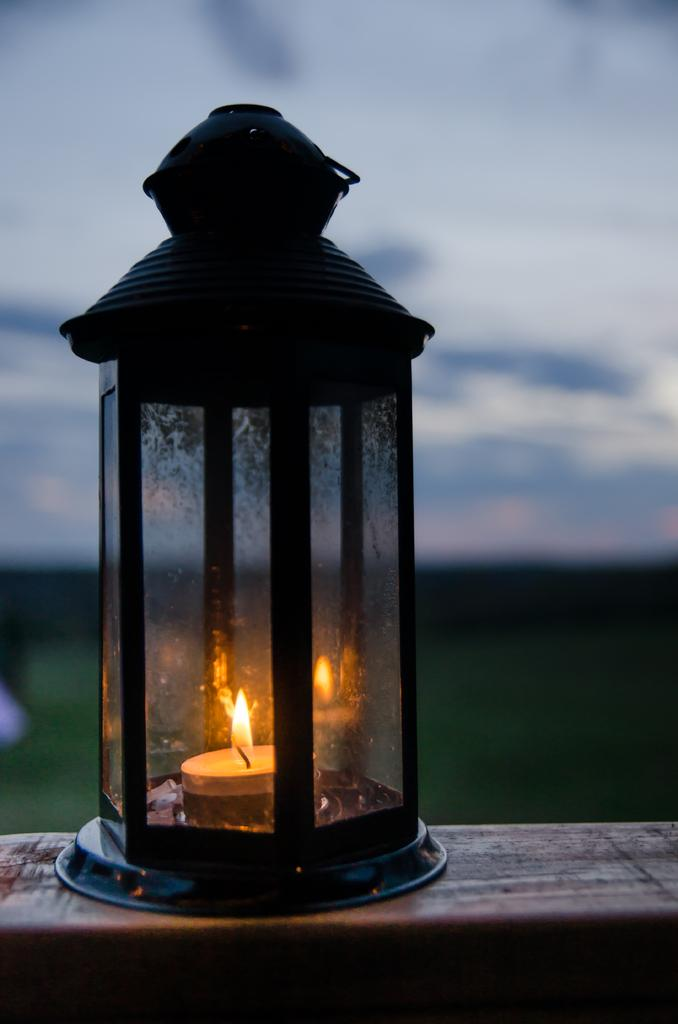What object is the main focus of the image? There is a lantern in the image. What is the lantern placed on? The lantern is on a wooden surface. Can you see anyone swimming in the image? There is no swimming or water visible in the image, so it cannot be determined if anyone is swimming. 